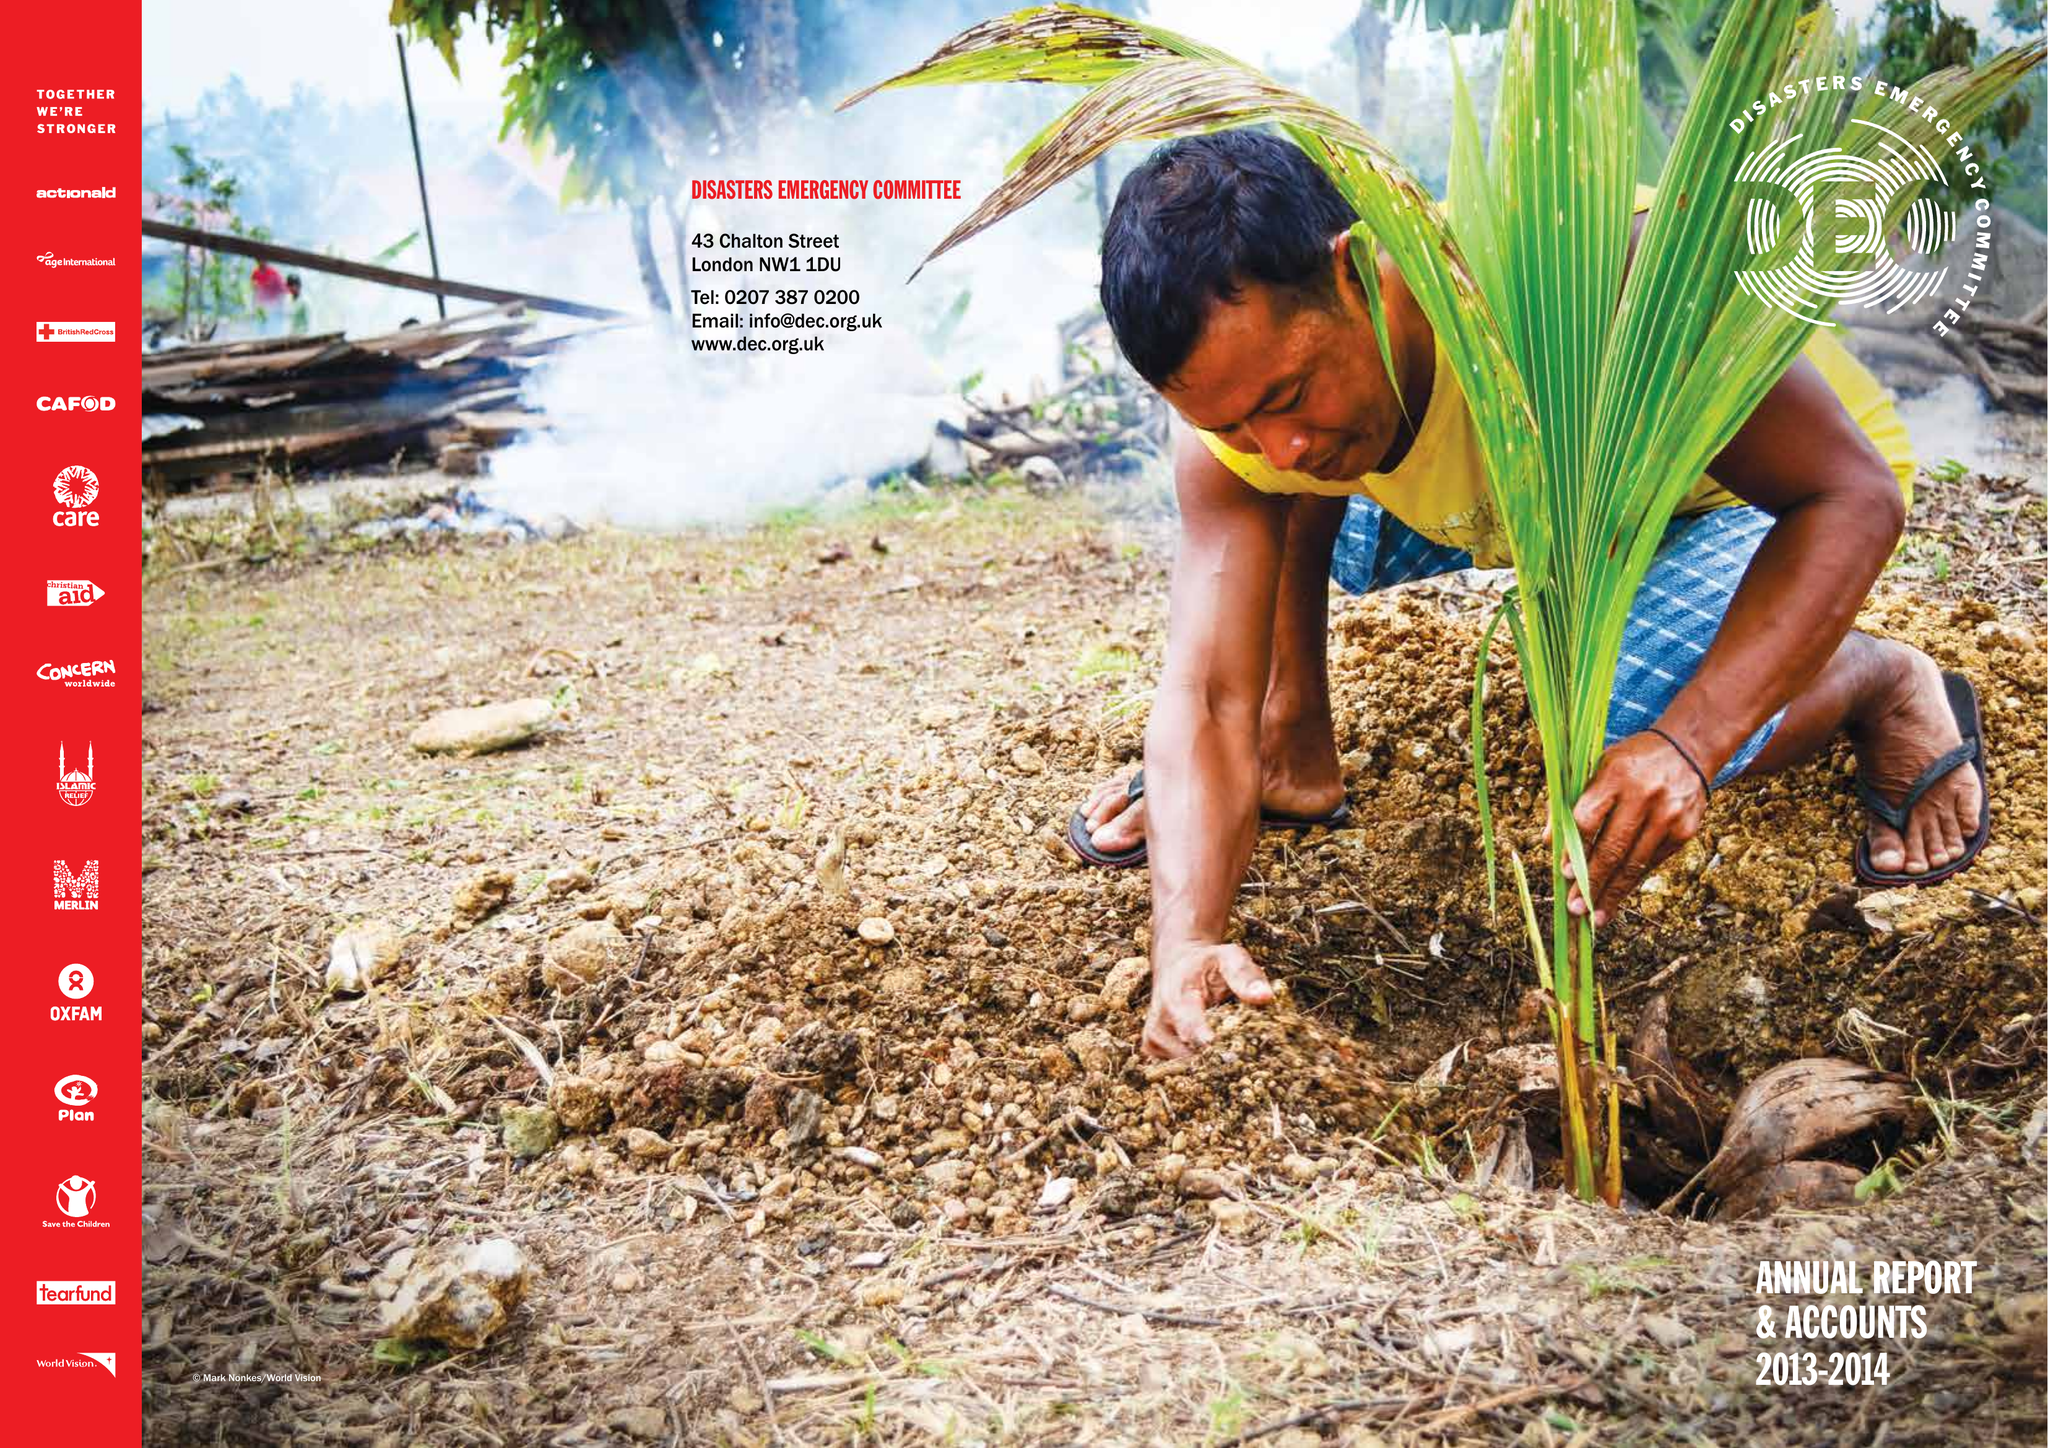What is the value for the address__street_line?
Answer the question using a single word or phrase. 1-6 TAVISTOCK SQUARE 